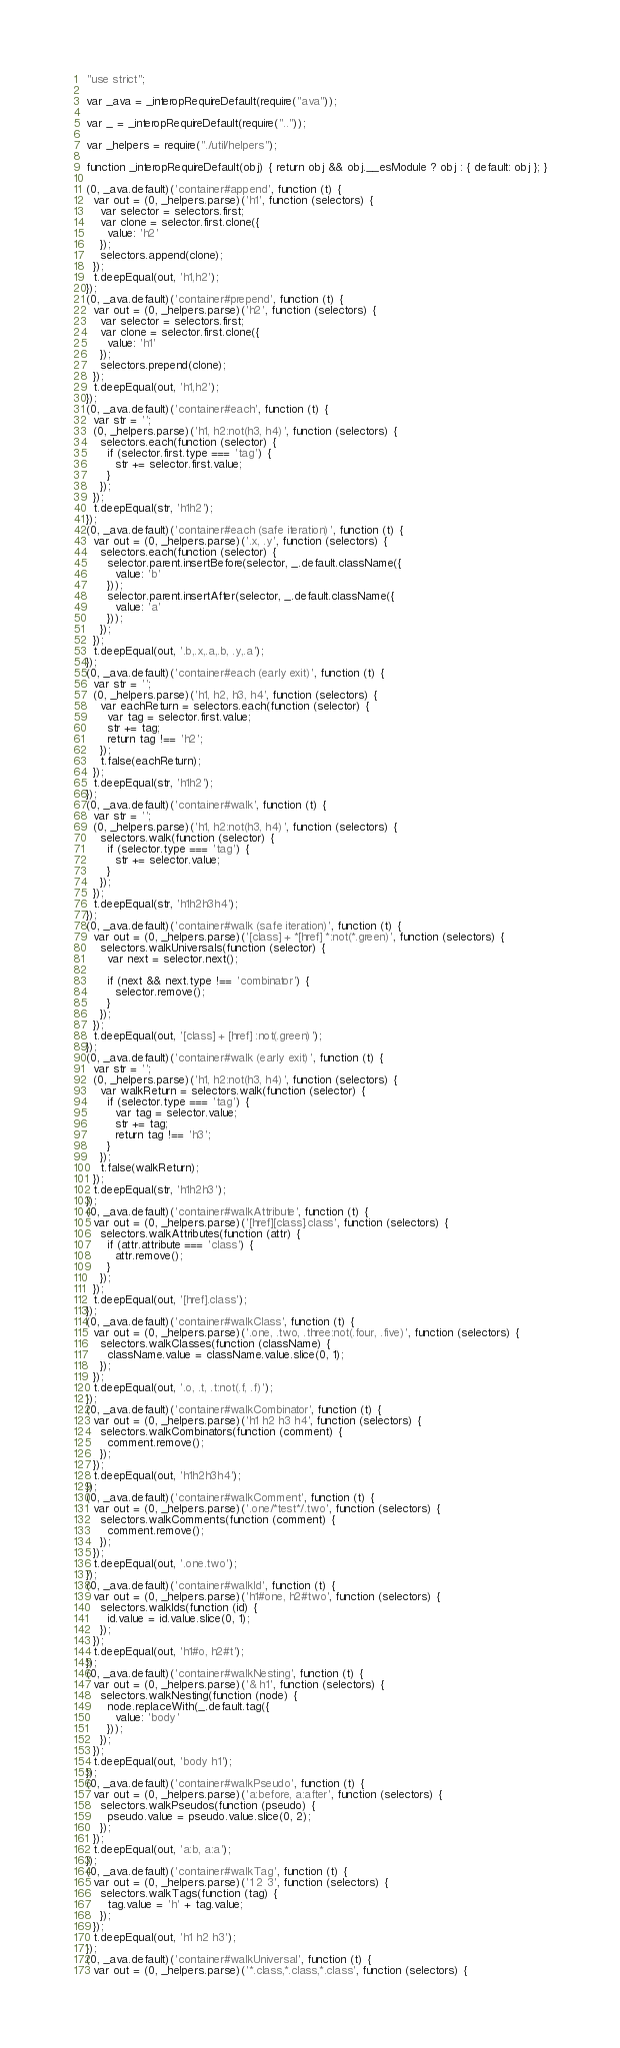<code> <loc_0><loc_0><loc_500><loc_500><_JavaScript_>"use strict";

var _ava = _interopRequireDefault(require("ava"));

var _ = _interopRequireDefault(require(".."));

var _helpers = require("./util/helpers");

function _interopRequireDefault(obj) { return obj && obj.__esModule ? obj : { default: obj }; }

(0, _ava.default)('container#append', function (t) {
  var out = (0, _helpers.parse)('h1', function (selectors) {
    var selector = selectors.first;
    var clone = selector.first.clone({
      value: 'h2'
    });
    selectors.append(clone);
  });
  t.deepEqual(out, 'h1,h2');
});
(0, _ava.default)('container#prepend', function (t) {
  var out = (0, _helpers.parse)('h2', function (selectors) {
    var selector = selectors.first;
    var clone = selector.first.clone({
      value: 'h1'
    });
    selectors.prepend(clone);
  });
  t.deepEqual(out, 'h1,h2');
});
(0, _ava.default)('container#each', function (t) {
  var str = '';
  (0, _helpers.parse)('h1, h2:not(h3, h4)', function (selectors) {
    selectors.each(function (selector) {
      if (selector.first.type === 'tag') {
        str += selector.first.value;
      }
    });
  });
  t.deepEqual(str, 'h1h2');
});
(0, _ava.default)('container#each (safe iteration)', function (t) {
  var out = (0, _helpers.parse)('.x, .y', function (selectors) {
    selectors.each(function (selector) {
      selector.parent.insertBefore(selector, _.default.className({
        value: 'b'
      }));
      selector.parent.insertAfter(selector, _.default.className({
        value: 'a'
      }));
    });
  });
  t.deepEqual(out, '.b,.x,.a,.b, .y,.a');
});
(0, _ava.default)('container#each (early exit)', function (t) {
  var str = '';
  (0, _helpers.parse)('h1, h2, h3, h4', function (selectors) {
    var eachReturn = selectors.each(function (selector) {
      var tag = selector.first.value;
      str += tag;
      return tag !== 'h2';
    });
    t.false(eachReturn);
  });
  t.deepEqual(str, 'h1h2');
});
(0, _ava.default)('container#walk', function (t) {
  var str = '';
  (0, _helpers.parse)('h1, h2:not(h3, h4)', function (selectors) {
    selectors.walk(function (selector) {
      if (selector.type === 'tag') {
        str += selector.value;
      }
    });
  });
  t.deepEqual(str, 'h1h2h3h4');
});
(0, _ava.default)('container#walk (safe iteration)', function (t) {
  var out = (0, _helpers.parse)('[class] + *[href] *:not(*.green)', function (selectors) {
    selectors.walkUniversals(function (selector) {
      var next = selector.next();

      if (next && next.type !== 'combinator') {
        selector.remove();
      }
    });
  });
  t.deepEqual(out, '[class] + [href] :not(.green)');
});
(0, _ava.default)('container#walk (early exit)', function (t) {
  var str = '';
  (0, _helpers.parse)('h1, h2:not(h3, h4)', function (selectors) {
    var walkReturn = selectors.walk(function (selector) {
      if (selector.type === 'tag') {
        var tag = selector.value;
        str += tag;
        return tag !== 'h3';
      }
    });
    t.false(walkReturn);
  });
  t.deepEqual(str, 'h1h2h3');
});
(0, _ava.default)('container#walkAttribute', function (t) {
  var out = (0, _helpers.parse)('[href][class].class', function (selectors) {
    selectors.walkAttributes(function (attr) {
      if (attr.attribute === 'class') {
        attr.remove();
      }
    });
  });
  t.deepEqual(out, '[href].class');
});
(0, _ava.default)('container#walkClass', function (t) {
  var out = (0, _helpers.parse)('.one, .two, .three:not(.four, .five)', function (selectors) {
    selectors.walkClasses(function (className) {
      className.value = className.value.slice(0, 1);
    });
  });
  t.deepEqual(out, '.o, .t, .t:not(.f, .f)');
});
(0, _ava.default)('container#walkCombinator', function (t) {
  var out = (0, _helpers.parse)('h1 h2 h3 h4', function (selectors) {
    selectors.walkCombinators(function (comment) {
      comment.remove();
    });
  });
  t.deepEqual(out, 'h1h2h3h4');
});
(0, _ava.default)('container#walkComment', function (t) {
  var out = (0, _helpers.parse)('.one/*test*/.two', function (selectors) {
    selectors.walkComments(function (comment) {
      comment.remove();
    });
  });
  t.deepEqual(out, '.one.two');
});
(0, _ava.default)('container#walkId', function (t) {
  var out = (0, _helpers.parse)('h1#one, h2#two', function (selectors) {
    selectors.walkIds(function (id) {
      id.value = id.value.slice(0, 1);
    });
  });
  t.deepEqual(out, 'h1#o, h2#t');
});
(0, _ava.default)('container#walkNesting', function (t) {
  var out = (0, _helpers.parse)('& h1', function (selectors) {
    selectors.walkNesting(function (node) {
      node.replaceWith(_.default.tag({
        value: 'body'
      }));
    });
  });
  t.deepEqual(out, 'body h1');
});
(0, _ava.default)('container#walkPseudo', function (t) {
  var out = (0, _helpers.parse)('a:before, a:after', function (selectors) {
    selectors.walkPseudos(function (pseudo) {
      pseudo.value = pseudo.value.slice(0, 2);
    });
  });
  t.deepEqual(out, 'a:b, a:a');
});
(0, _ava.default)('container#walkTag', function (t) {
  var out = (0, _helpers.parse)('1 2 3', function (selectors) {
    selectors.walkTags(function (tag) {
      tag.value = 'h' + tag.value;
    });
  });
  t.deepEqual(out, 'h1 h2 h3');
});
(0, _ava.default)('container#walkUniversal', function (t) {
  var out = (0, _helpers.parse)('*.class,*.class,*.class', function (selectors) {</code> 